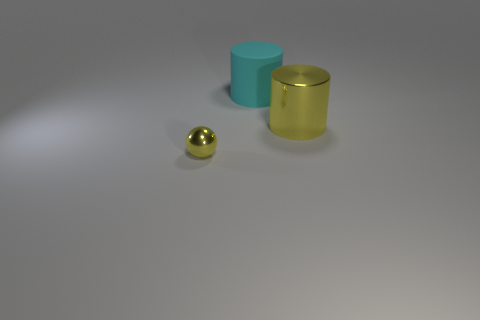There is a yellow object on the left side of the metal cylinder; does it have the same size as the large cyan rubber cylinder?
Offer a terse response. No. How many objects are either objects that are behind the tiny yellow object or big brown metal cubes?
Your answer should be very brief. 2. Is there another cylinder that has the same size as the cyan matte cylinder?
Ensure brevity in your answer.  Yes. There is another thing that is the same size as the cyan object; what is it made of?
Ensure brevity in your answer.  Metal. What shape is the object that is on the left side of the big shiny object and in front of the matte thing?
Offer a very short reply. Sphere. The shiny object that is behind the tiny thing is what color?
Offer a terse response. Yellow. What size is the object that is both in front of the big cyan object and left of the big metallic cylinder?
Provide a succinct answer. Small. Are the large yellow object and the thing to the left of the big cyan matte cylinder made of the same material?
Your answer should be very brief. Yes. What number of other things have the same shape as the large rubber object?
Provide a short and direct response. 1. How many large purple blocks are there?
Make the answer very short. 0. 